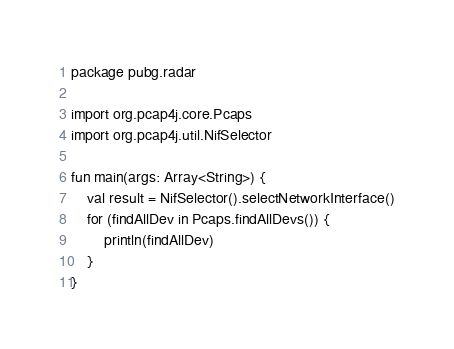<code> <loc_0><loc_0><loc_500><loc_500><_Kotlin_>package pubg.radar

import org.pcap4j.core.Pcaps
import org.pcap4j.util.NifSelector

fun main(args: Array<String>) {
    val result = NifSelector().selectNetworkInterface()
    for (findAllDev in Pcaps.findAllDevs()) {
        println(findAllDev)
    }
}</code> 